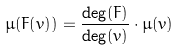<formula> <loc_0><loc_0><loc_500><loc_500>\mu ( F ( v ) ) = \frac { \deg ( F ) } { \deg ( v ) } \cdot \mu ( v )</formula> 